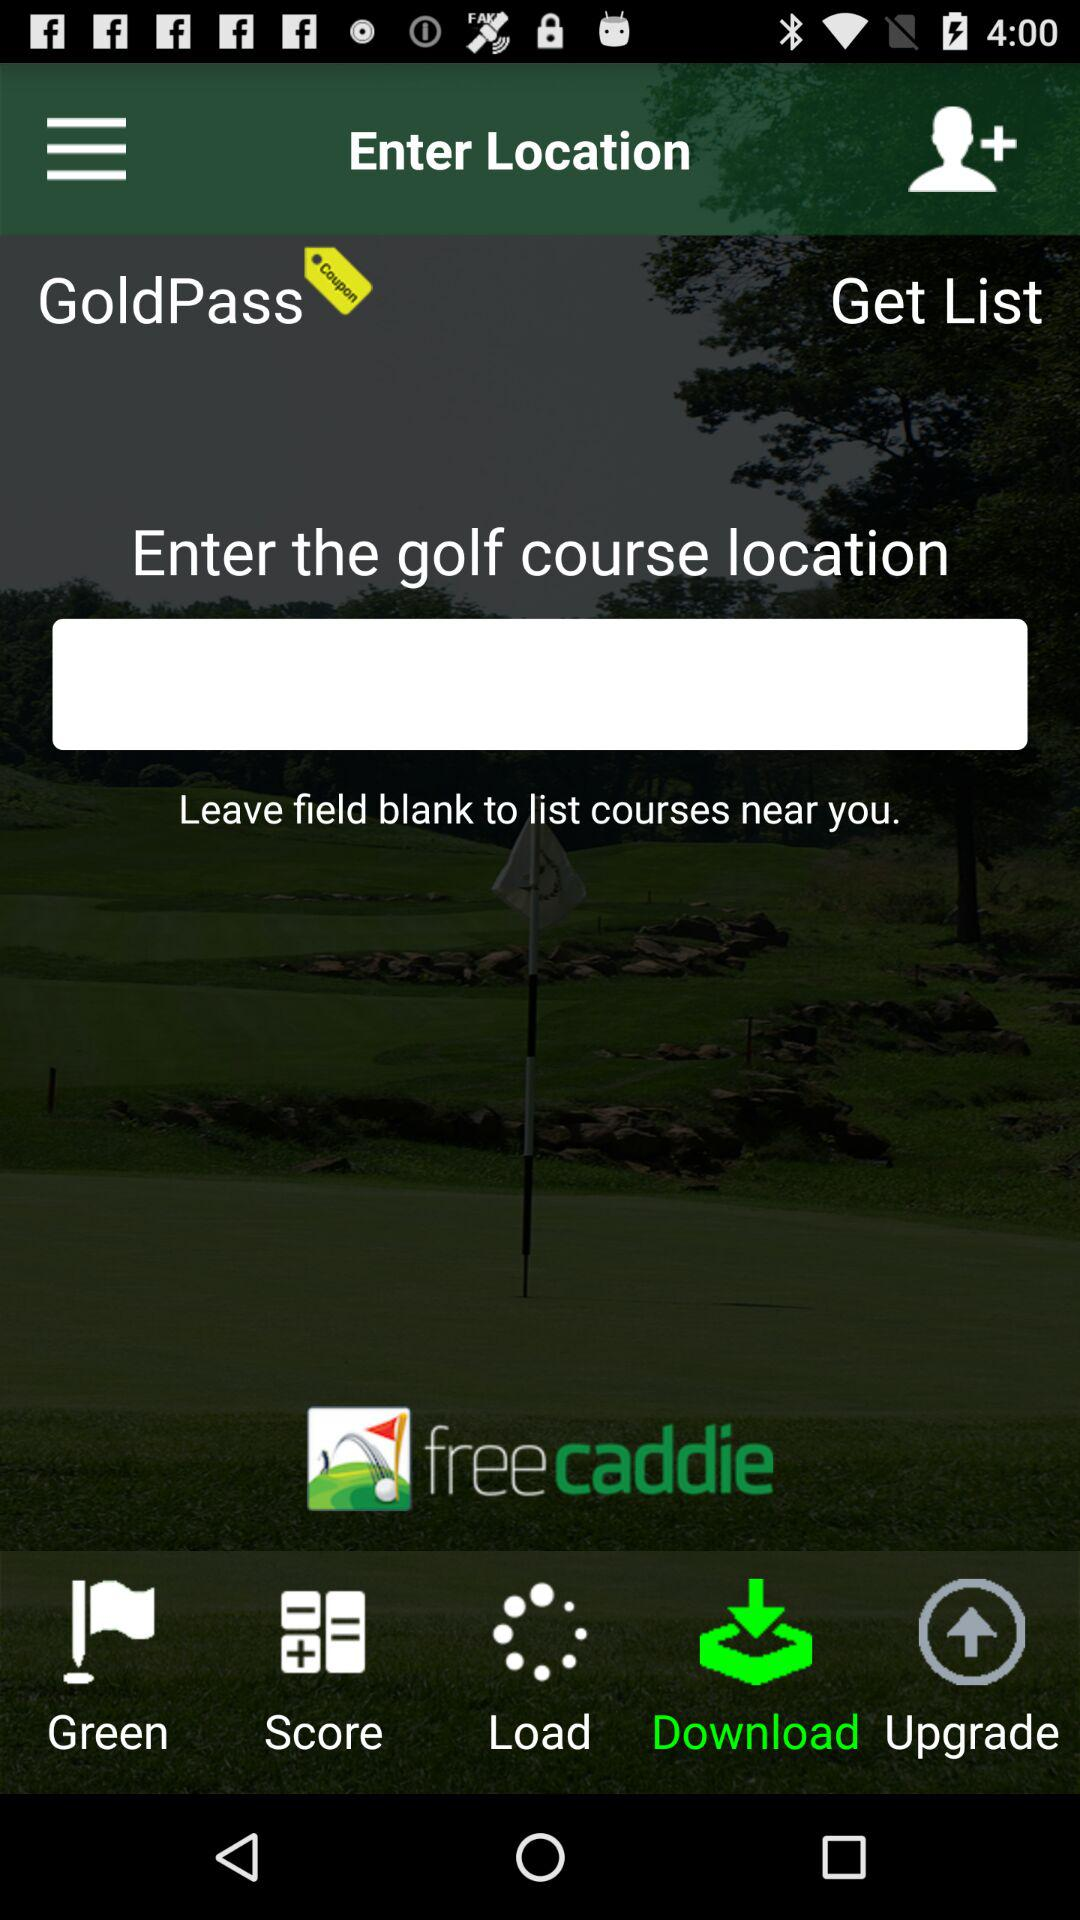Which tab is selected? The selected tab is "Download". 